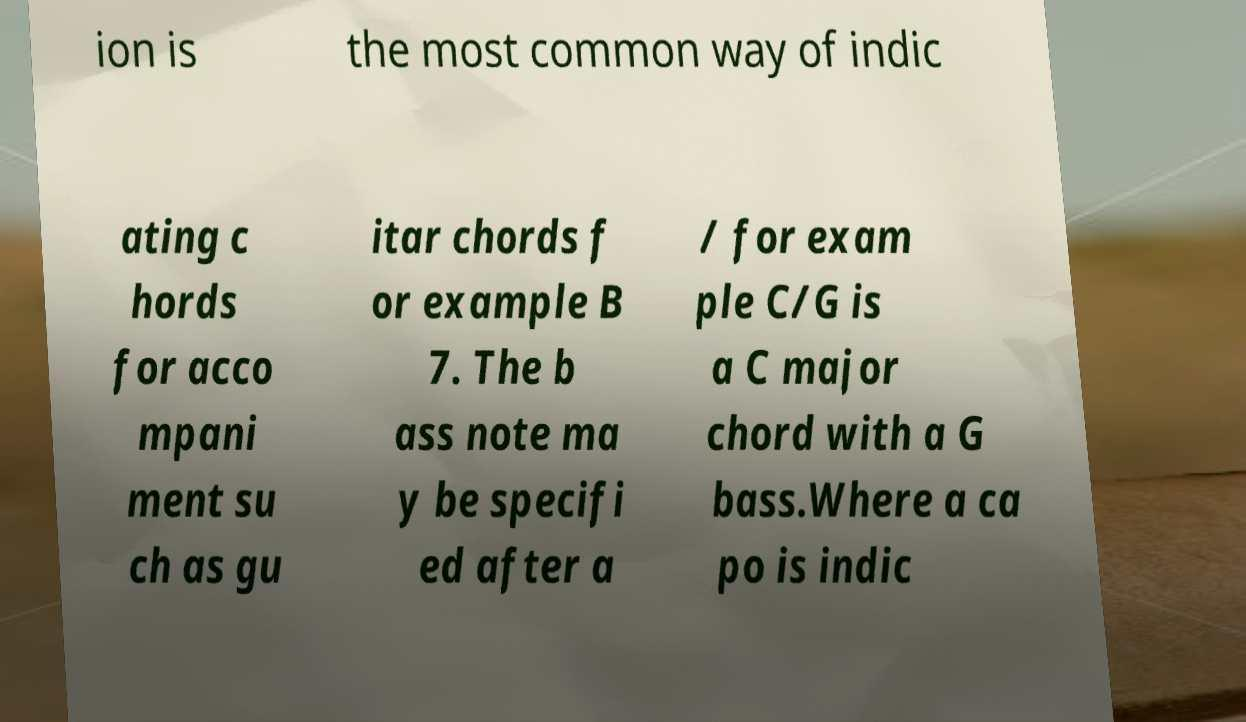Please read and relay the text visible in this image. What does it say? ion is the most common way of indic ating c hords for acco mpani ment su ch as gu itar chords f or example B 7. The b ass note ma y be specifi ed after a / for exam ple C/G is a C major chord with a G bass.Where a ca po is indic 